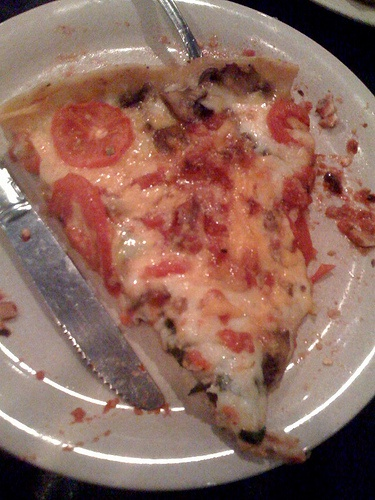Describe the objects in this image and their specific colors. I can see pizza in navy, brown, and salmon tones, knife in navy, gray, darkgray, and white tones, and fork in navy, gray, darkgray, and black tones in this image. 